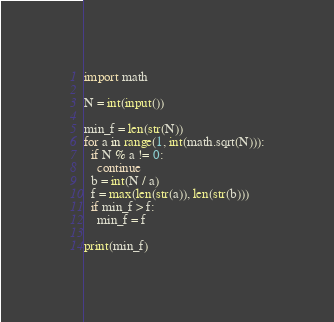Convert code to text. <code><loc_0><loc_0><loc_500><loc_500><_Python_>import math

N = int(input())

min_f = len(str(N))
for a in range(1, int(math.sqrt(N))):
  if N % a != 0:
    continue
  b = int(N / a)
  f = max(len(str(a)), len(str(b)))
  if min_f > f:
    min_f = f

print(min_f)</code> 